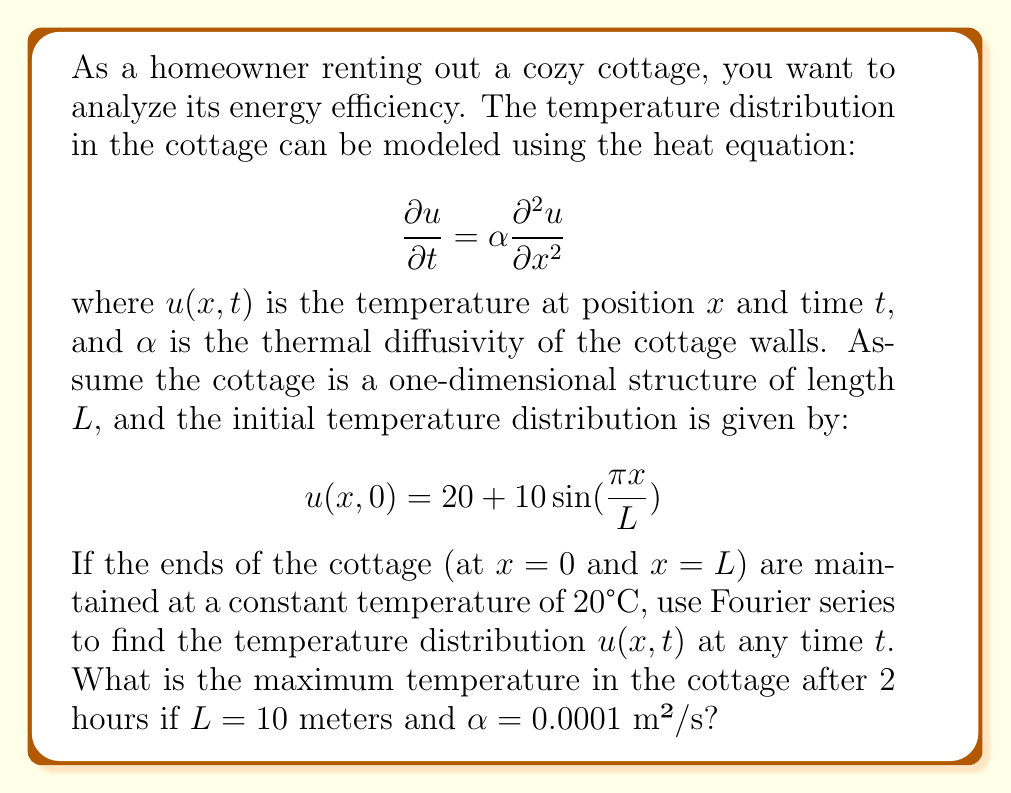Show me your answer to this math problem. To solve this problem, we'll follow these steps:

1) First, we need to find the general solution of the heat equation using separation of variables:
   $$u(x,t) = \sum_{n=1}^{\infty} B_n \sin(\frac{n\pi x}{L}) e^{-\alpha(\frac{n\pi}{L})^2t}$$

2) The initial condition is:
   $$u(x,0) = 20 + 10\sin(\frac{\pi x}{L})$$

3) Comparing this with our general solution, we can see that:
   - $B_1 = 10$ (coefficient of $\sin(\frac{\pi x}{L})$)
   - $B_n = 0$ for $n > 1$
   - We need to add a constant term of 20

4) Therefore, our specific solution is:
   $$u(x,t) = 20 + 10\sin(\frac{\pi x}{L}) e^{-\alpha(\frac{\pi}{L})^2t}$$

5) Now, let's substitute the given values:
   $L = 10$ meters
   $\alpha = 0.0001$ m²/s
   $t = 2$ hours = 7200 seconds

6) Our solution becomes:
   $$u(x,7200) = 20 + 10\sin(\frac{\pi x}{10}) e^{-0.0001(\frac{\pi}{10})^2 * 7200}$$

7) To find the maximum temperature, we need to find the maximum value of $\sin(\frac{\pi x}{10})$, which is 1, occurring at $x = 5$ meters.

8) Calculate the exponential term:
   $$e^{-0.0001(\frac{\pi}{10})^2 * 7200} \approx 0.4966$$

9) Therefore, the maximum temperature is:
   $$u_{max} = 20 + 10 * 1 * 0.4966 = 24.966°C$$
Answer: The maximum temperature in the cottage after 2 hours is approximately 24.966°C. 